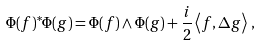<formula> <loc_0><loc_0><loc_500><loc_500>\Phi ( f ) ^ { * } \Phi ( g ) = \Phi ( f ) \wedge \Phi ( g ) + \frac { i } { 2 } \left < f , \Delta g \right > \, ,</formula> 